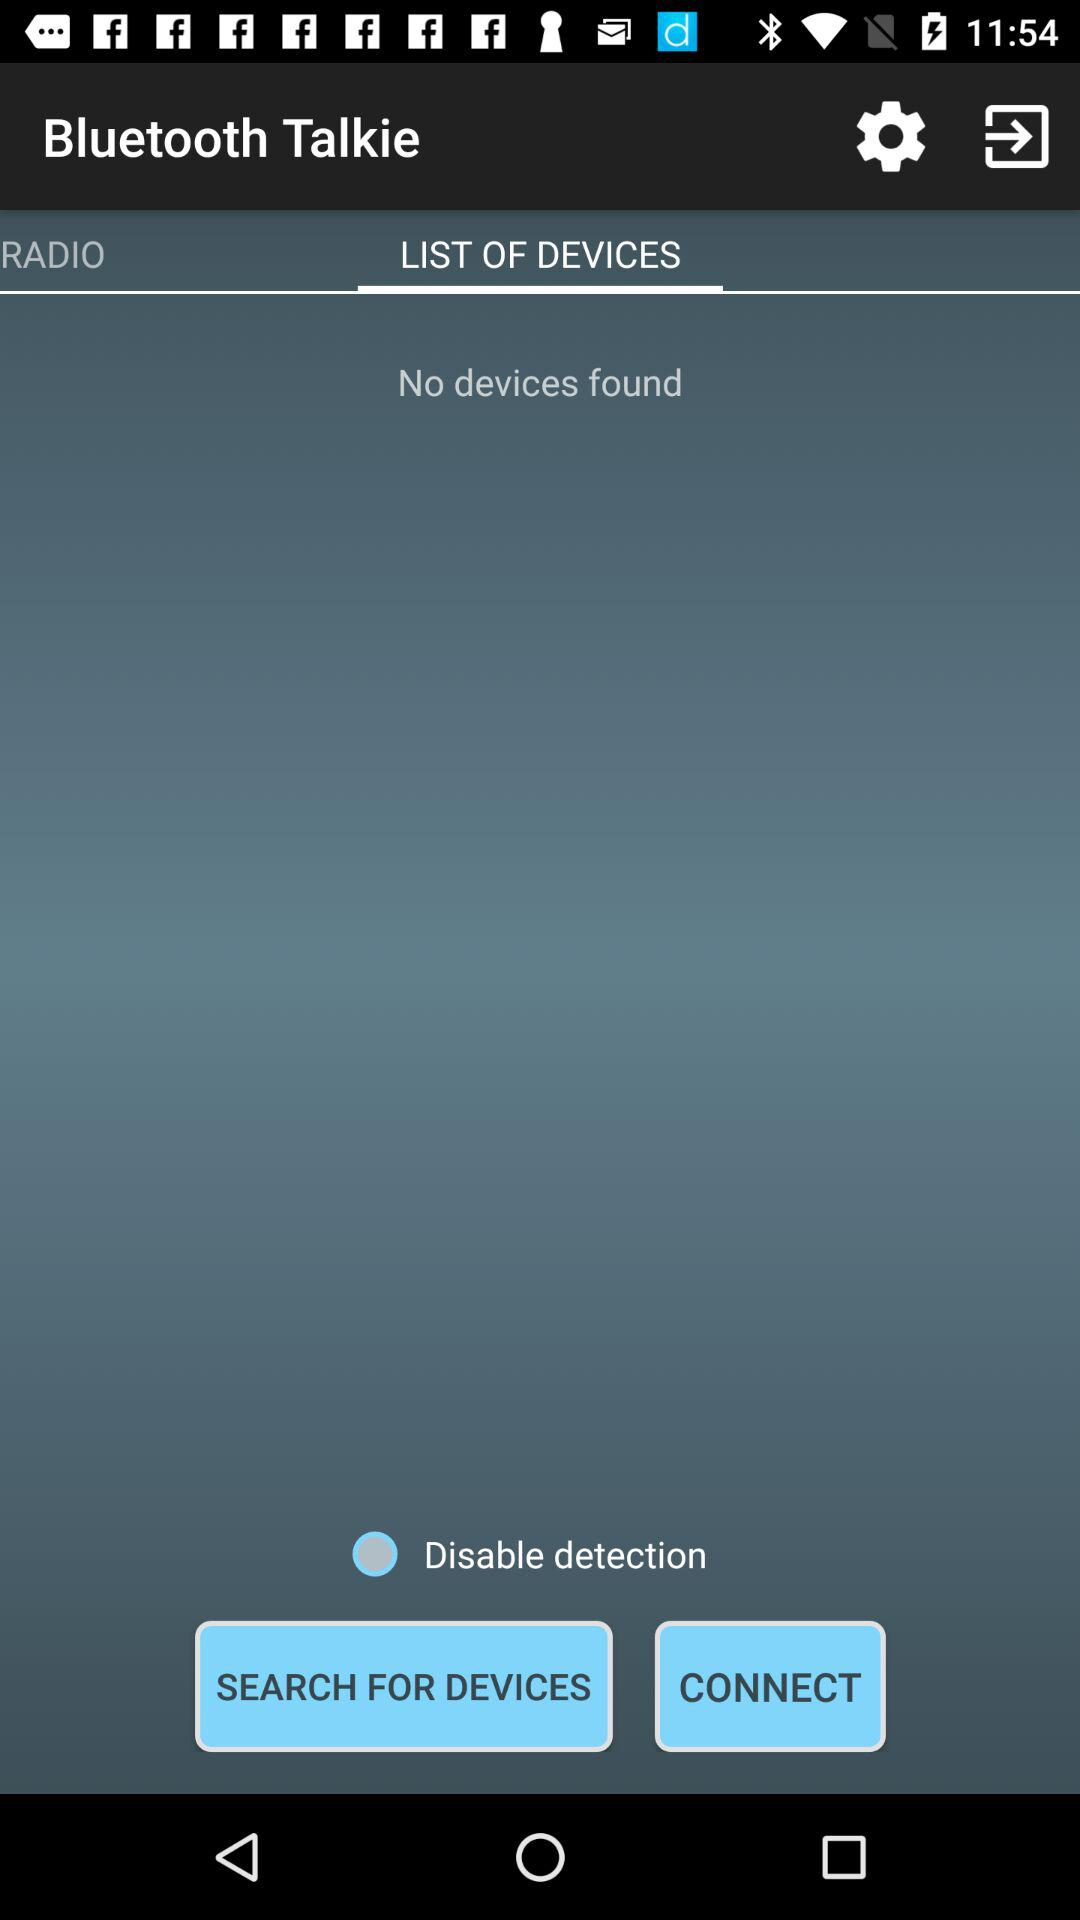Which tab is selected? The selected tab is "LIST OF DEVICES". 